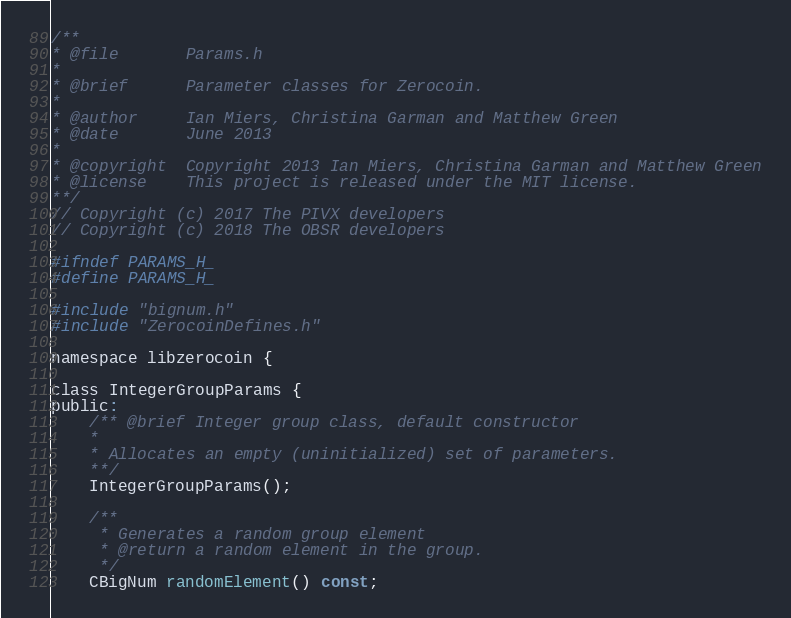<code> <loc_0><loc_0><loc_500><loc_500><_C_>/**
* @file       Params.h
*
* @brief      Parameter classes for Zerocoin.
*
* @author     Ian Miers, Christina Garman and Matthew Green
* @date       June 2013
*
* @copyright  Copyright 2013 Ian Miers, Christina Garman and Matthew Green
* @license    This project is released under the MIT license.
**/
// Copyright (c) 2017 The PIVX developers
// Copyright (c) 2018 The OBSR developers

#ifndef PARAMS_H_
#define PARAMS_H_

#include "bignum.h"
#include "ZerocoinDefines.h"

namespace libzerocoin {

class IntegerGroupParams {
public:
	/** @brief Integer group class, default constructor
	*
	* Allocates an empty (uninitialized) set of parameters.
	**/
	IntegerGroupParams();

	/**
	 * Generates a random group element
	 * @return a random element in the group.
	 */
	CBigNum randomElement() const;</code> 